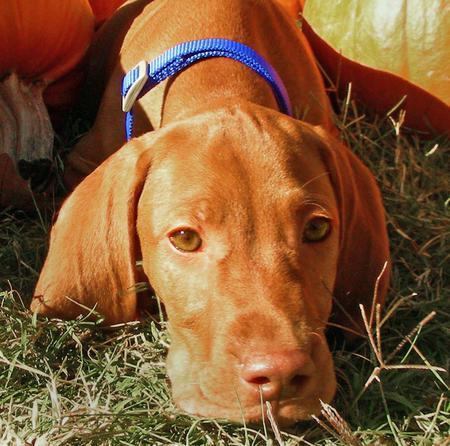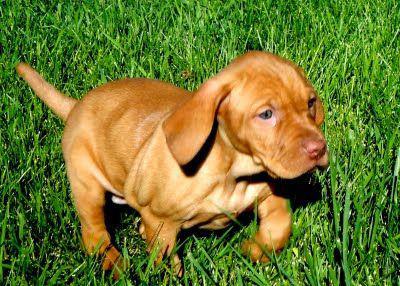The first image is the image on the left, the second image is the image on the right. Evaluate the accuracy of this statement regarding the images: "Each image contains exactly one red-orange dog, one image shows a puppy headed across the grass with a front paw raised, and the other shows a dog wearing a bluish collar.". Is it true? Answer yes or no. Yes. The first image is the image on the left, the second image is the image on the right. Analyze the images presented: Is the assertion "The dog in the image on the left is standing in the grass." valid? Answer yes or no. No. 